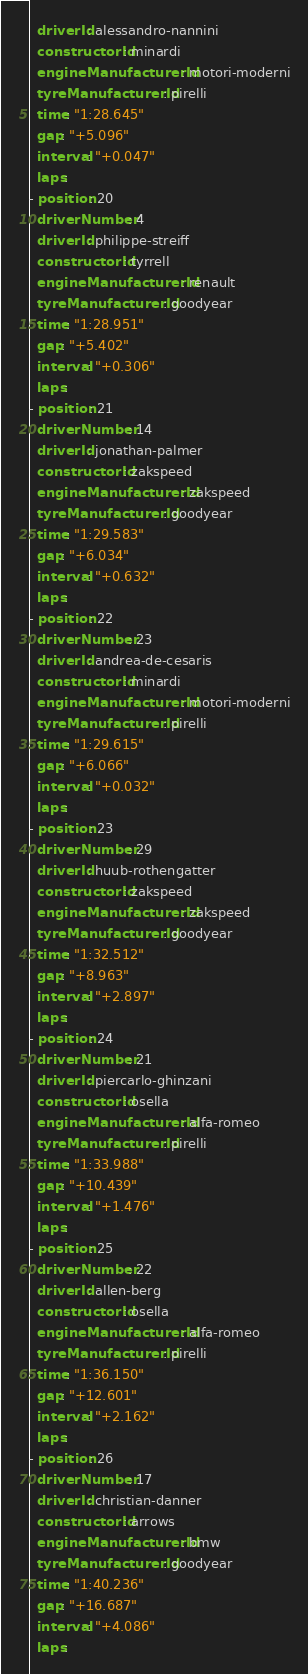Convert code to text. <code><loc_0><loc_0><loc_500><loc_500><_YAML_>  driverId: alessandro-nannini
  constructorId: minardi
  engineManufacturerId: motori-moderni
  tyreManufacturerId: pirelli
  time: "1:28.645"
  gap: "+5.096"
  interval: "+0.047"
  laps:
- position: 20
  driverNumber: 4
  driverId: philippe-streiff
  constructorId: tyrrell
  engineManufacturerId: renault
  tyreManufacturerId: goodyear
  time: "1:28.951"
  gap: "+5.402"
  interval: "+0.306"
  laps:
- position: 21
  driverNumber: 14
  driverId: jonathan-palmer
  constructorId: zakspeed
  engineManufacturerId: zakspeed
  tyreManufacturerId: goodyear
  time: "1:29.583"
  gap: "+6.034"
  interval: "+0.632"
  laps:
- position: 22
  driverNumber: 23
  driverId: andrea-de-cesaris
  constructorId: minardi
  engineManufacturerId: motori-moderni
  tyreManufacturerId: pirelli
  time: "1:29.615"
  gap: "+6.066"
  interval: "+0.032"
  laps:
- position: 23
  driverNumber: 29
  driverId: huub-rothengatter
  constructorId: zakspeed
  engineManufacturerId: zakspeed
  tyreManufacturerId: goodyear
  time: "1:32.512"
  gap: "+8.963"
  interval: "+2.897"
  laps:
- position: 24
  driverNumber: 21
  driverId: piercarlo-ghinzani
  constructorId: osella
  engineManufacturerId: alfa-romeo
  tyreManufacturerId: pirelli
  time: "1:33.988"
  gap: "+10.439"
  interval: "+1.476"
  laps:
- position: 25
  driverNumber: 22
  driverId: allen-berg
  constructorId: osella
  engineManufacturerId: alfa-romeo
  tyreManufacturerId: pirelli
  time: "1:36.150"
  gap: "+12.601"
  interval: "+2.162"
  laps:
- position: 26
  driverNumber: 17
  driverId: christian-danner
  constructorId: arrows
  engineManufacturerId: bmw
  tyreManufacturerId: goodyear
  time: "1:40.236"
  gap: "+16.687"
  interval: "+4.086"
  laps:
</code> 